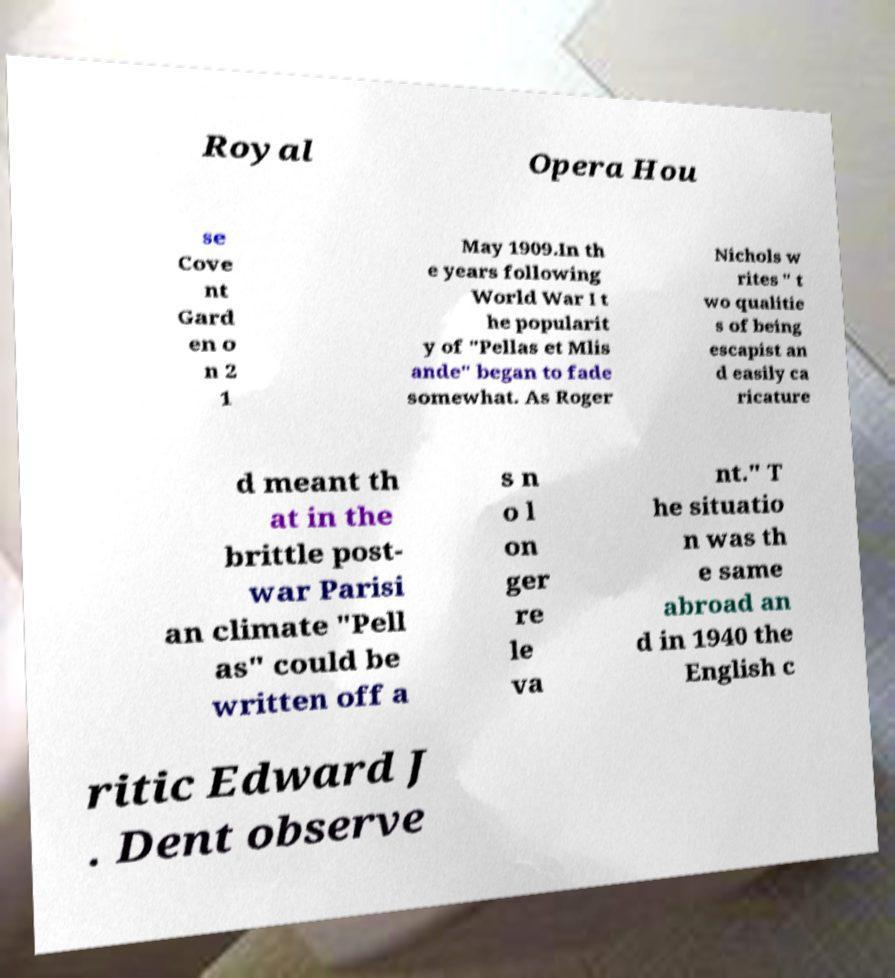Please read and relay the text visible in this image. What does it say? Royal Opera Hou se Cove nt Gard en o n 2 1 May 1909.In th e years following World War I t he popularit y of "Pellas et Mlis ande" began to fade somewhat. As Roger Nichols w rites " t wo qualitie s of being escapist an d easily ca ricature d meant th at in the brittle post- war Parisi an climate "Pell as" could be written off a s n o l on ger re le va nt." T he situatio n was th e same abroad an d in 1940 the English c ritic Edward J . Dent observe 